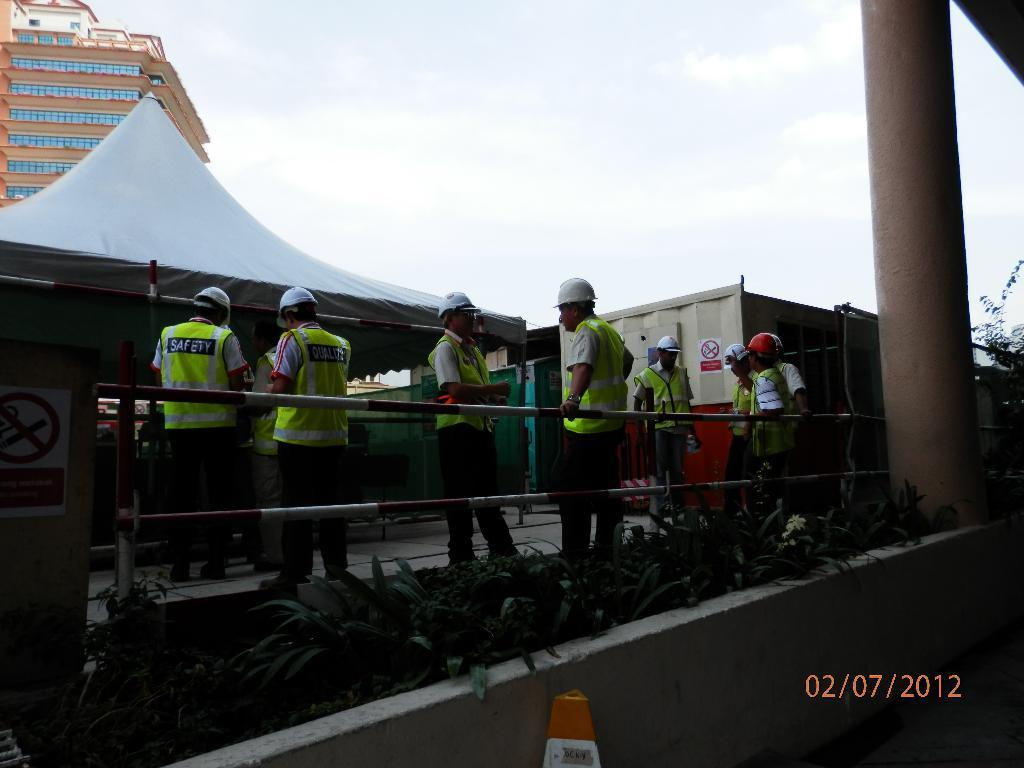What are the people in the image doing? The people in the image are standing beside a fence. What structure can be seen in the image besides the fence? There is a tent and a building in the image. What type of blade is being used to cut the tent in the image? There is no blade or cutting activity present in the image; the tent is intact. How does the heat affect the people standing beside the fence in the image? The provided facts do not mention any heat or temperature information, so we cannot determine how it affects the people in the image. 